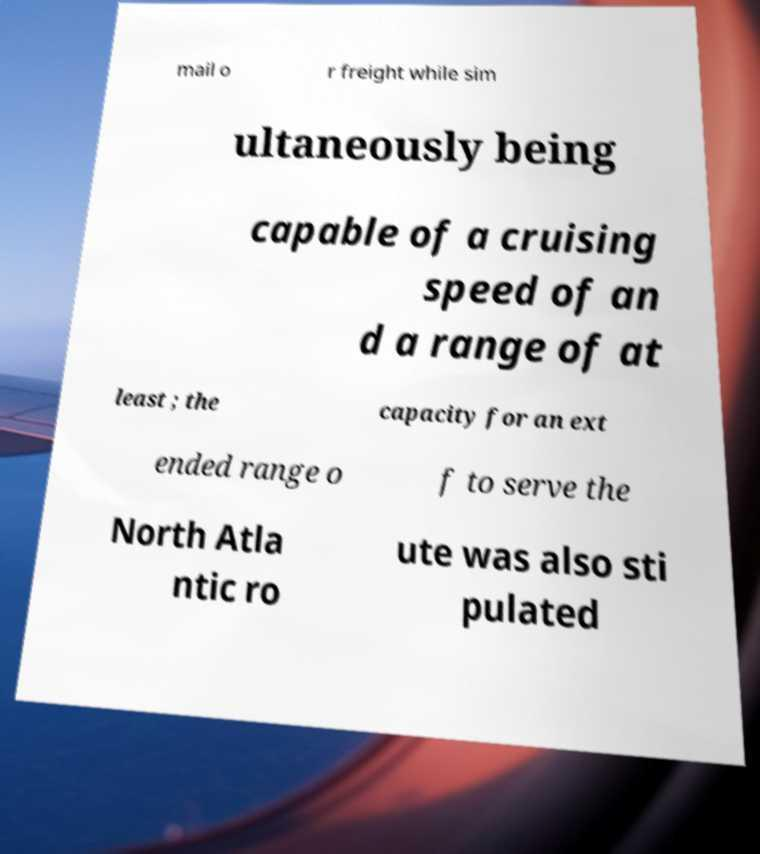What messages or text are displayed in this image? I need them in a readable, typed format. mail o r freight while sim ultaneously being capable of a cruising speed of an d a range of at least ; the capacity for an ext ended range o f to serve the North Atla ntic ro ute was also sti pulated 